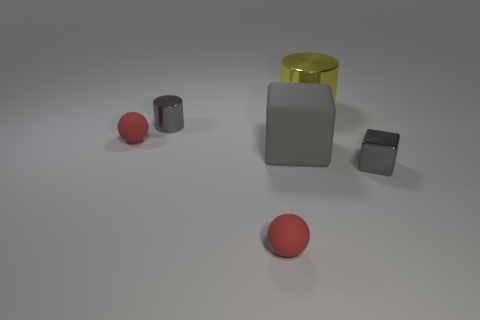Add 4 gray metallic cylinders. How many objects exist? 10 Subtract all spheres. How many objects are left? 4 Subtract 0 brown cylinders. How many objects are left? 6 Subtract all gray metal blocks. Subtract all gray metal objects. How many objects are left? 3 Add 5 gray rubber blocks. How many gray rubber blocks are left? 6 Add 5 gray shiny cubes. How many gray shiny cubes exist? 6 